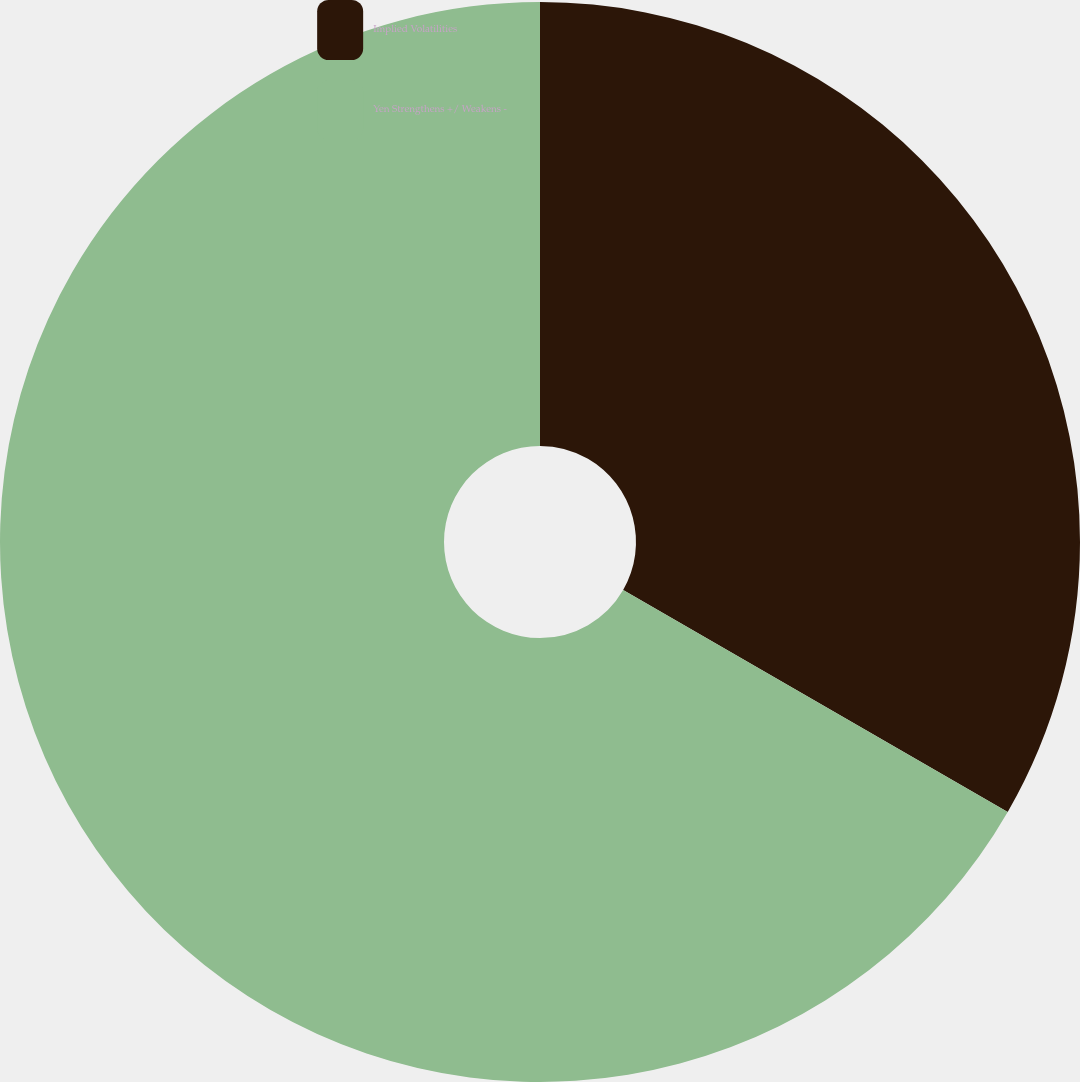Convert chart. <chart><loc_0><loc_0><loc_500><loc_500><pie_chart><fcel>Implied Volatilities<fcel>Yen Strengthens +/ Weakens -<nl><fcel>33.33%<fcel>66.67%<nl></chart> 